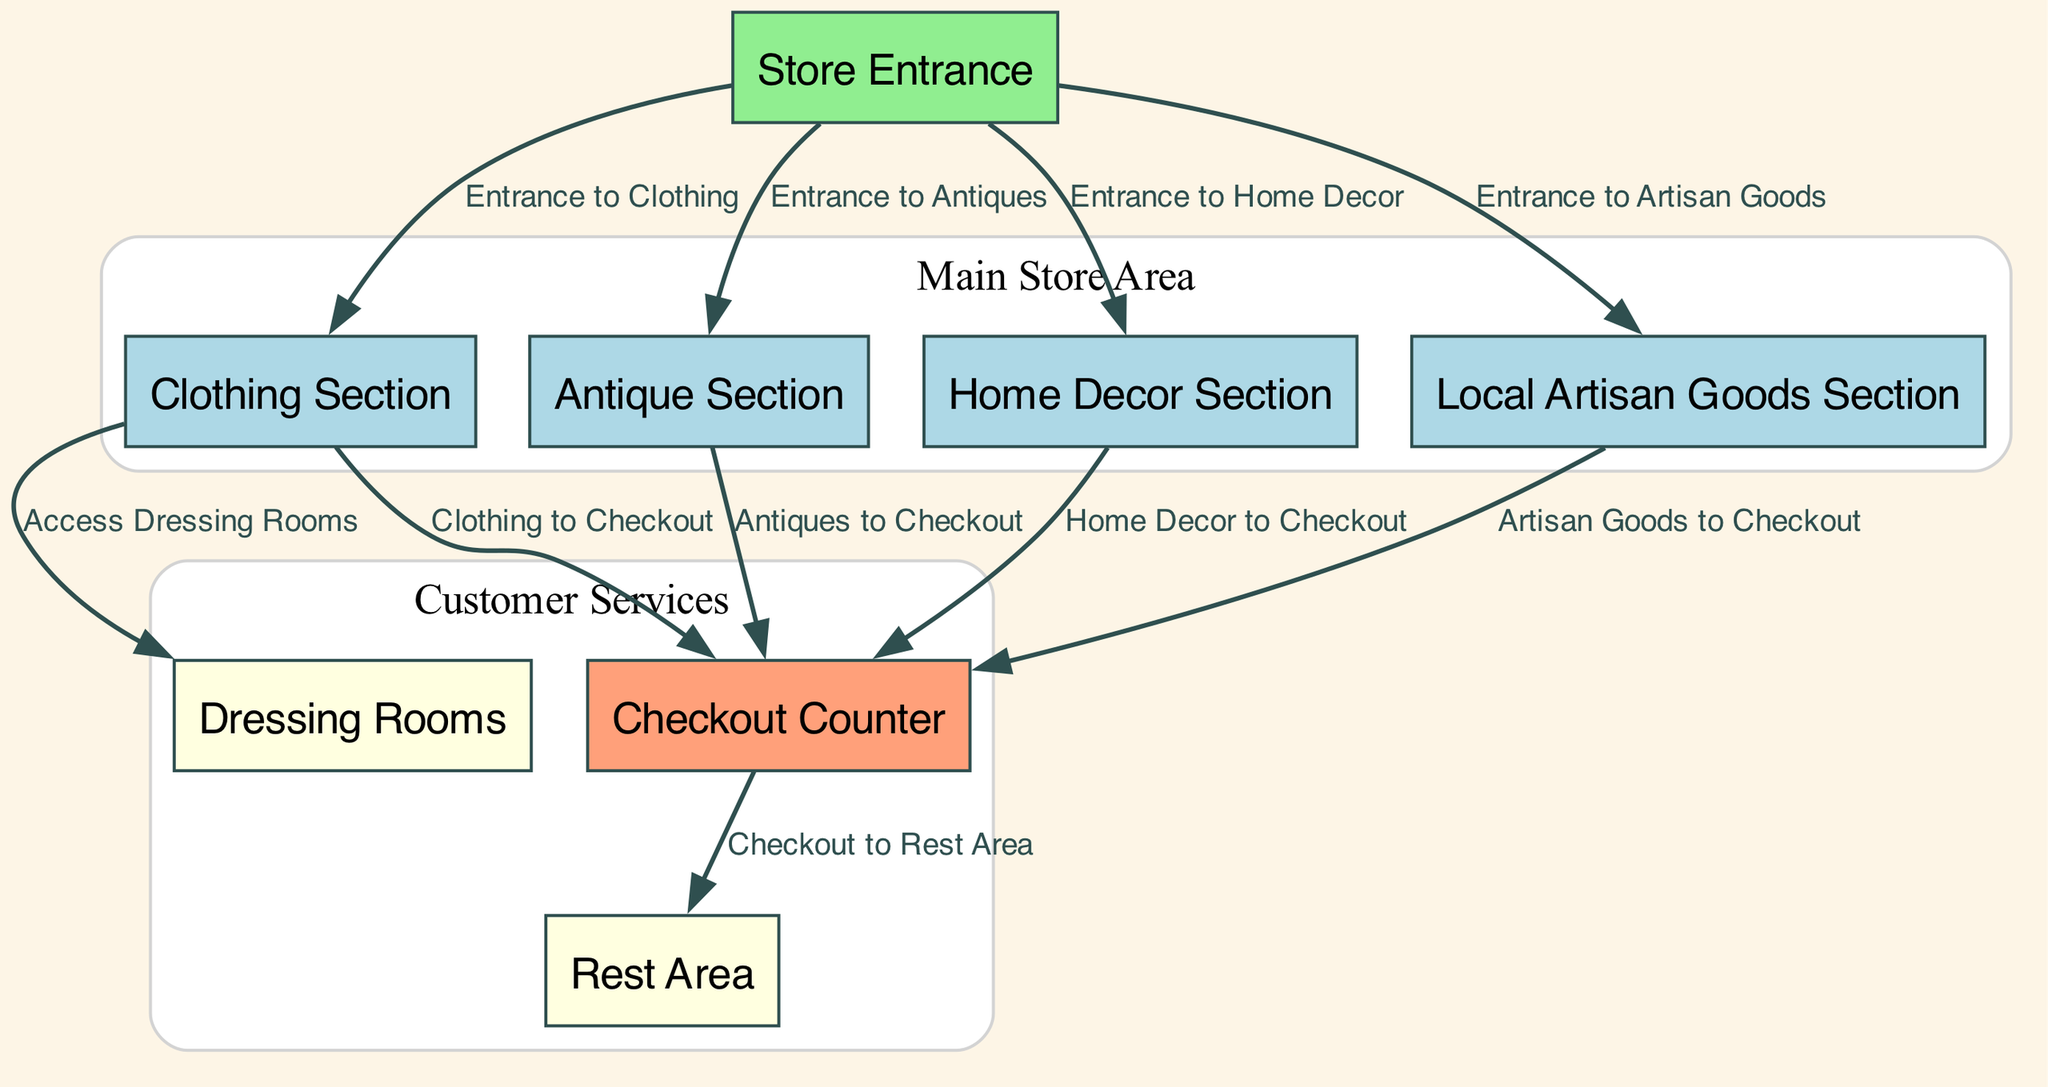What are the sections of the vintage store? The diagram lists four main sections: Clothing Section, Antique Section, Home Decor Section, and Local Artisan Goods Section. Each section is represented as a node in the diagram, indicating their distinct categories.
Answer: Clothing Section, Antique Section, Home Decor Section, Local Artisan Goods Section How many main sections are there in the store? The diagram shows four distinct sections (Clothing, Antiques, Home Decor, Artisan Goods), which are connected to the Store Entrance, representing the main areas for customer browsing.
Answer: Four Which section leads to the Dressing Rooms? The edge from the Clothing Section to the Dressing Rooms indicates that the only section providing access to the Dressing Rooms is the Clothing Section, where customers can try on clothes.
Answer: Clothing Section What is the route from the Antique Section to the Checkout Counter? The route from the Antique Section to the Checkout Counter follows a direct edge labeled "Antiques to Checkout," indicating there is no intermediary pathway involved, making it a straightforward path.
Answer: Antiques to Checkout What is the connection between the Checkout Counter and the Rest Area? The diagram shows a direct edge labeled "Checkout to Rest Area" from the Checkout Counter to the Rest Area, suggesting that customers can access the Rest Area immediately after checkout.
Answer: Checkout to Rest Area Which sections can be entered directly from the Store Entrance? The diagram shows edges from the Store Entrance to four sections: Clothing Section, Antique Section, Home Decor Section, and Local Artisan Goods Section, indicating that customers can access these areas right after entering.
Answer: Clothing Section, Antique Section, Home Decor Section, Local Artisan Goods Section Are the Dressing Rooms part of the main store area? The Dressing Rooms are connected to the Clothing Section but are separately categorized under Customer Services in the diagram, indicating they are not part of the main store area's section layout.
Answer: No What colors represent different sections in the diagram? The Clothing Section, Antique Section, Home Decor Section, and Local Artisan Goods Section are all colored light blue, while the Store Entrance is light green and the Checkout Counter is light salmon, indicating their distinct functions in the layout.
Answer: Light blue, light green, light salmon How many edges connect the Clothing Section to other nodes? The Clothing Section has three edges: one leading to the Dressing Rooms, one to the Checkout Counter, and one coming from the Store Entrance, indicating several pathways from this section to other areas in the store.
Answer: Three 